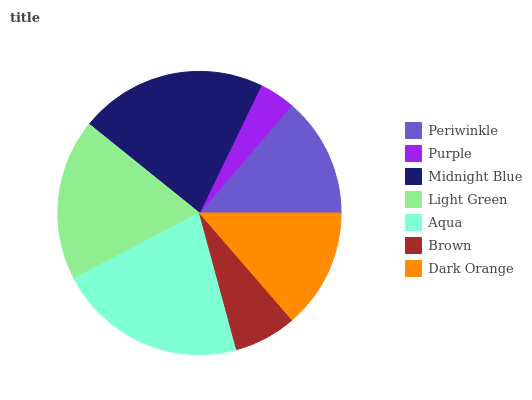Is Purple the minimum?
Answer yes or no. Yes. Is Aqua the maximum?
Answer yes or no. Yes. Is Midnight Blue the minimum?
Answer yes or no. No. Is Midnight Blue the maximum?
Answer yes or no. No. Is Midnight Blue greater than Purple?
Answer yes or no. Yes. Is Purple less than Midnight Blue?
Answer yes or no. Yes. Is Purple greater than Midnight Blue?
Answer yes or no. No. Is Midnight Blue less than Purple?
Answer yes or no. No. Is Periwinkle the high median?
Answer yes or no. Yes. Is Periwinkle the low median?
Answer yes or no. Yes. Is Purple the high median?
Answer yes or no. No. Is Purple the low median?
Answer yes or no. No. 